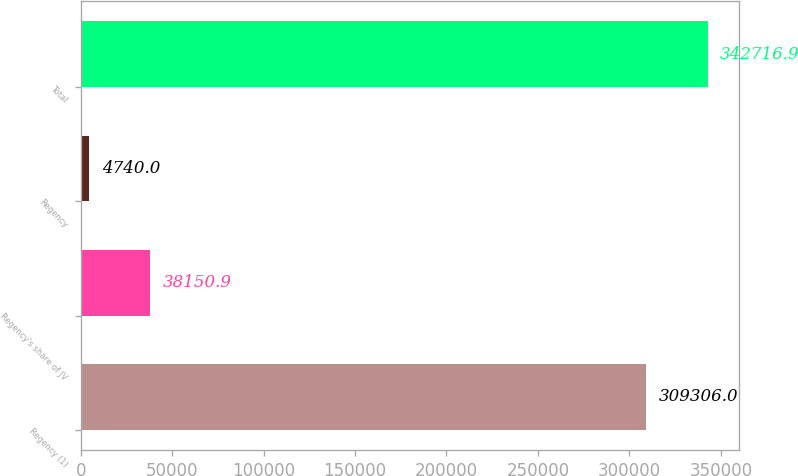Convert chart. <chart><loc_0><loc_0><loc_500><loc_500><bar_chart><fcel>Regency (1)<fcel>Regency's share of JV<fcel>Regency<fcel>Total<nl><fcel>309306<fcel>38150.9<fcel>4740<fcel>342717<nl></chart> 